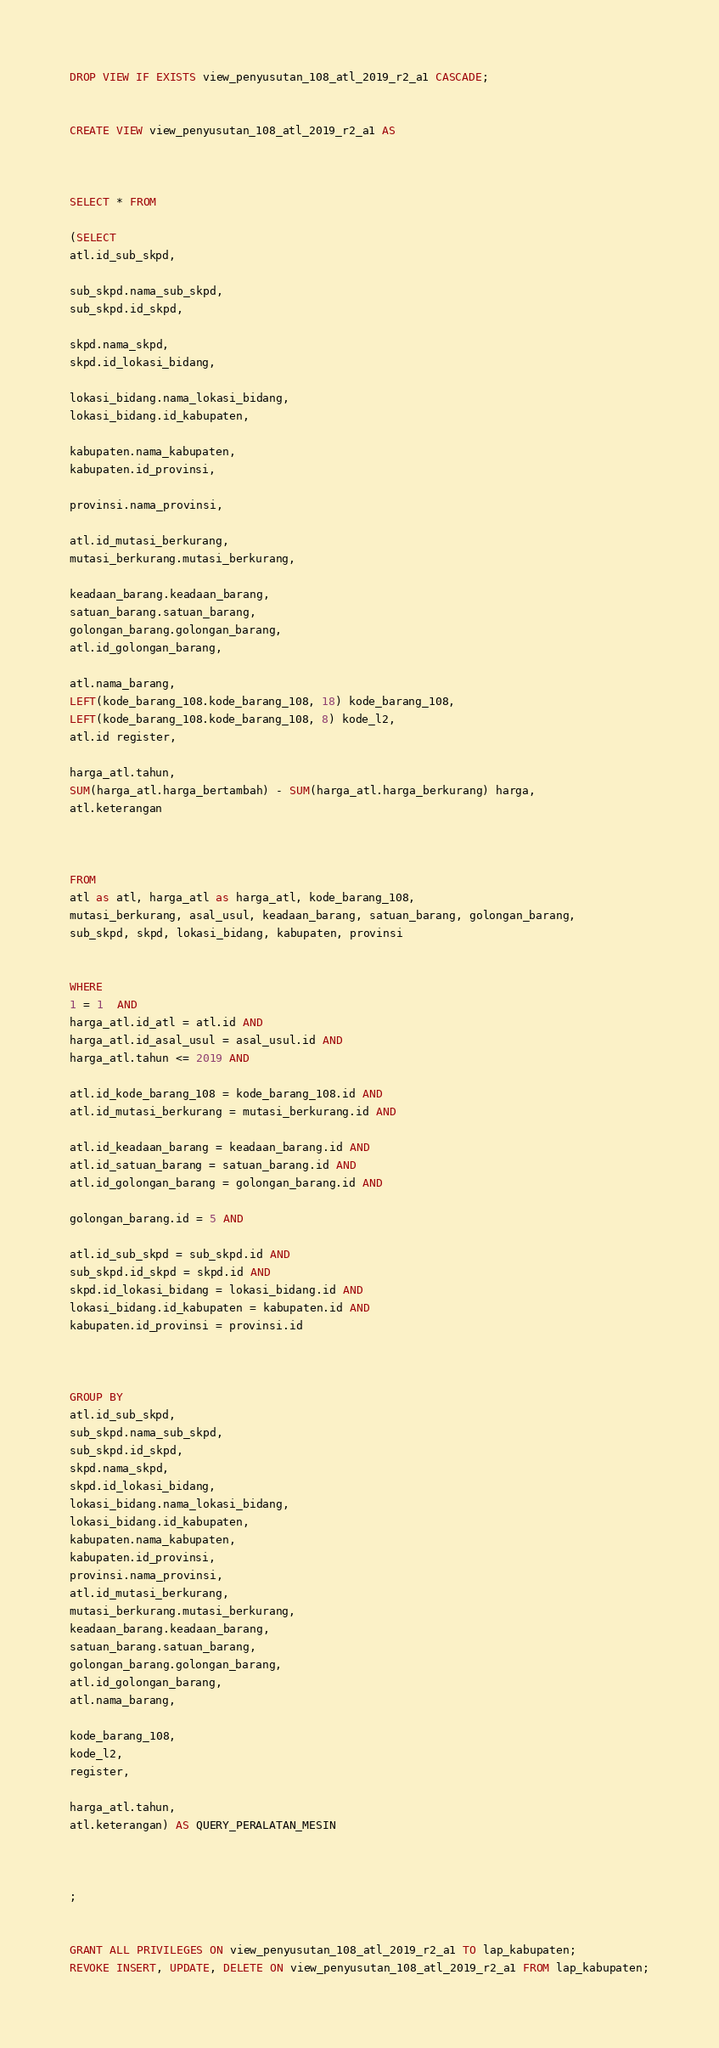Convert code to text. <code><loc_0><loc_0><loc_500><loc_500><_SQL_>DROP VIEW IF EXISTS view_penyusutan_108_atl_2019_r2_a1 CASCADE;


CREATE VIEW view_penyusutan_108_atl_2019_r2_a1 AS



SELECT * FROM

(SELECT
atl.id_sub_skpd,

sub_skpd.nama_sub_skpd,
sub_skpd.id_skpd,

skpd.nama_skpd,
skpd.id_lokasi_bidang,

lokasi_bidang.nama_lokasi_bidang,
lokasi_bidang.id_kabupaten,

kabupaten.nama_kabupaten,
kabupaten.id_provinsi,

provinsi.nama_provinsi,

atl.id_mutasi_berkurang,
mutasi_berkurang.mutasi_berkurang,

keadaan_barang.keadaan_barang,
satuan_barang.satuan_barang,
golongan_barang.golongan_barang,
atl.id_golongan_barang,

atl.nama_barang,
LEFT(kode_barang_108.kode_barang_108, 18) kode_barang_108,
LEFT(kode_barang_108.kode_barang_108, 8) kode_l2,
atl.id register,

harga_atl.tahun,
SUM(harga_atl.harga_bertambah) - SUM(harga_atl.harga_berkurang) harga,
atl.keterangan



FROM
atl as atl, harga_atl as harga_atl, kode_barang_108,
mutasi_berkurang, asal_usul, keadaan_barang, satuan_barang, golongan_barang,
sub_skpd, skpd, lokasi_bidang, kabupaten, provinsi


WHERE
1 = 1  AND
harga_atl.id_atl = atl.id AND
harga_atl.id_asal_usul = asal_usul.id AND
harga_atl.tahun <= 2019 AND

atl.id_kode_barang_108 = kode_barang_108.id AND
atl.id_mutasi_berkurang = mutasi_berkurang.id AND

atl.id_keadaan_barang = keadaan_barang.id AND
atl.id_satuan_barang = satuan_barang.id AND
atl.id_golongan_barang = golongan_barang.id AND

golongan_barang.id = 5 AND

atl.id_sub_skpd = sub_skpd.id AND
sub_skpd.id_skpd = skpd.id AND
skpd.id_lokasi_bidang = lokasi_bidang.id AND
lokasi_bidang.id_kabupaten = kabupaten.id AND
kabupaten.id_provinsi = provinsi.id



GROUP BY
atl.id_sub_skpd,
sub_skpd.nama_sub_skpd,
sub_skpd.id_skpd,
skpd.nama_skpd,
skpd.id_lokasi_bidang,
lokasi_bidang.nama_lokasi_bidang,
lokasi_bidang.id_kabupaten,
kabupaten.nama_kabupaten,
kabupaten.id_provinsi,
provinsi.nama_provinsi,
atl.id_mutasi_berkurang,
mutasi_berkurang.mutasi_berkurang,
keadaan_barang.keadaan_barang,
satuan_barang.satuan_barang,
golongan_barang.golongan_barang,
atl.id_golongan_barang,
atl.nama_barang,

kode_barang_108,
kode_l2,
register,

harga_atl.tahun,
atl.keterangan) AS QUERY_PERALATAN_MESIN



;


GRANT ALL PRIVILEGES ON view_penyusutan_108_atl_2019_r2_a1 TO lap_kabupaten;
REVOKE INSERT, UPDATE, DELETE ON view_penyusutan_108_atl_2019_r2_a1 FROM lap_kabupaten;
</code> 